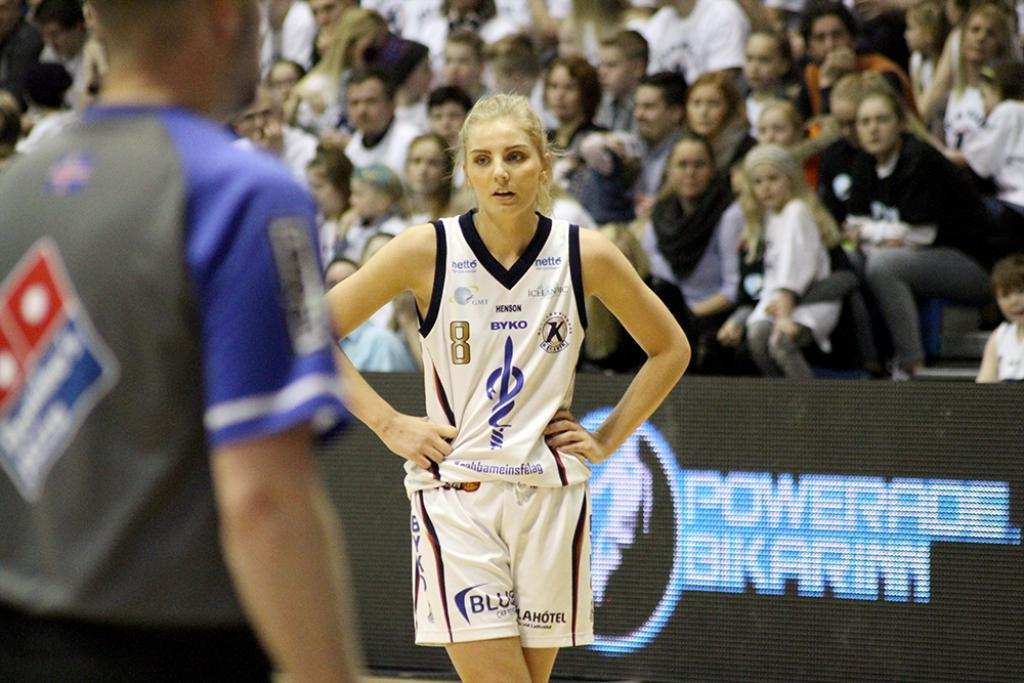<image>
Summarize the visual content of the image. a basketball player is standing next to a powerade advertisement. 